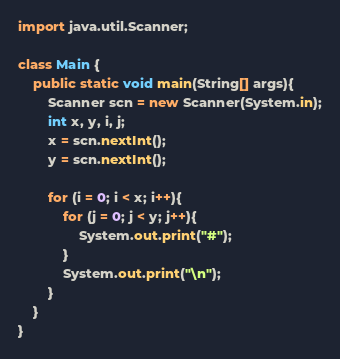<code> <loc_0><loc_0><loc_500><loc_500><_Java_>import java.util.Scanner;

class Main {
	public static void main(String[] args){
		Scanner scn = new Scanner(System.in);
		int x, y, i, j;
		x = scn.nextInt();
		y = scn.nextInt();
		
		for (i = 0; i < x; i++){
			for (j = 0; j < y; j++){
				System.out.print("#");
			}
			System.out.print("\n");
		}
	}
}</code> 